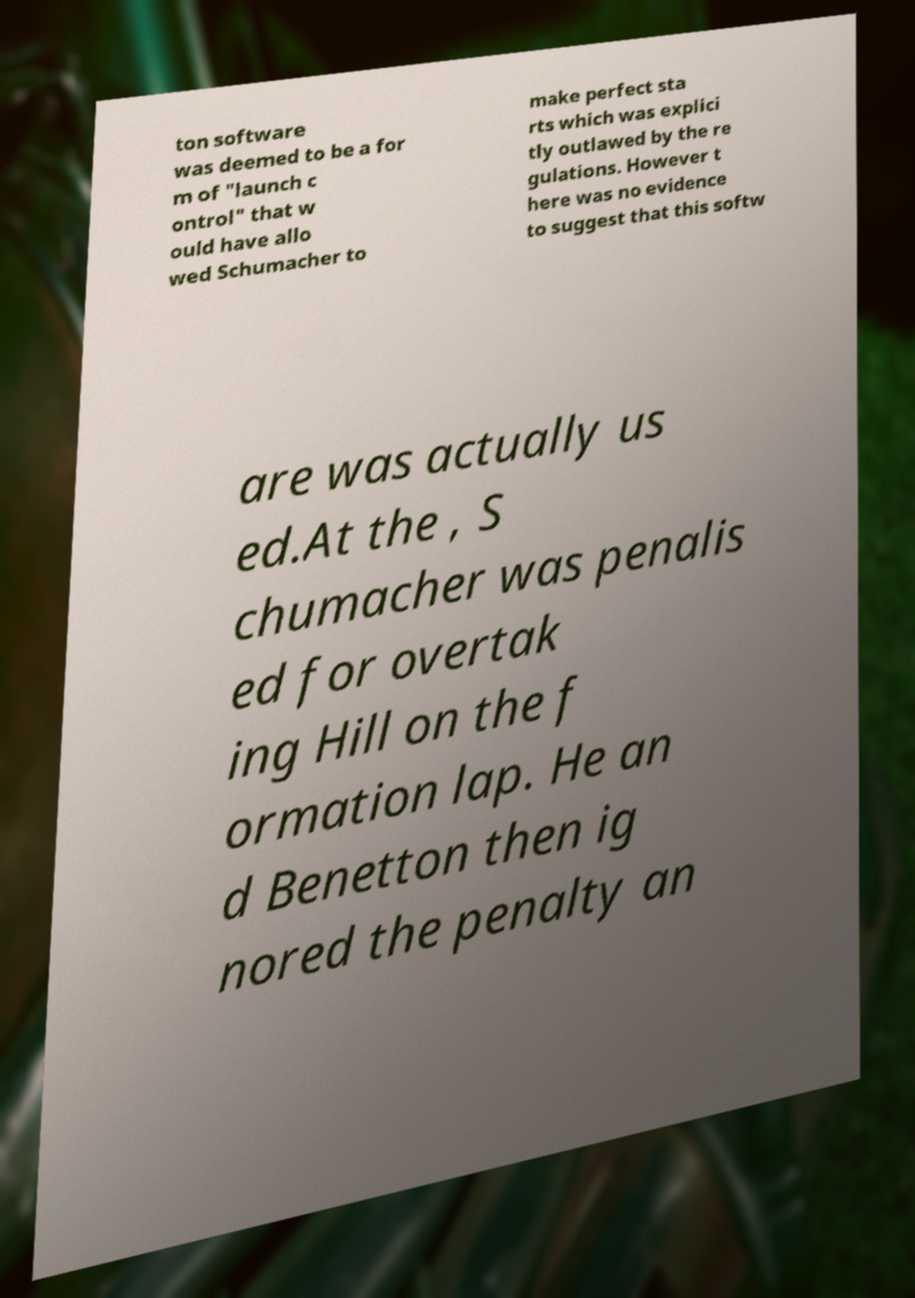Please identify and transcribe the text found in this image. ton software was deemed to be a for m of "launch c ontrol" that w ould have allo wed Schumacher to make perfect sta rts which was explici tly outlawed by the re gulations. However t here was no evidence to suggest that this softw are was actually us ed.At the , S chumacher was penalis ed for overtak ing Hill on the f ormation lap. He an d Benetton then ig nored the penalty an 